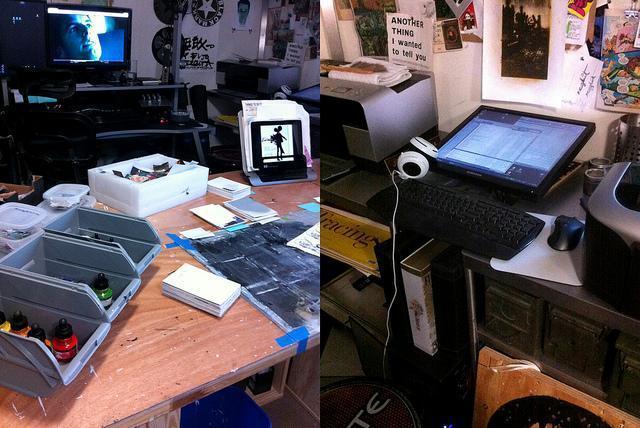How many tvs are in the photo?
Give a very brief answer. 2. How many chairs are there?
Give a very brief answer. 1. How many books are there?
Give a very brief answer. 2. How many people are wearing a checked top?
Give a very brief answer. 0. 